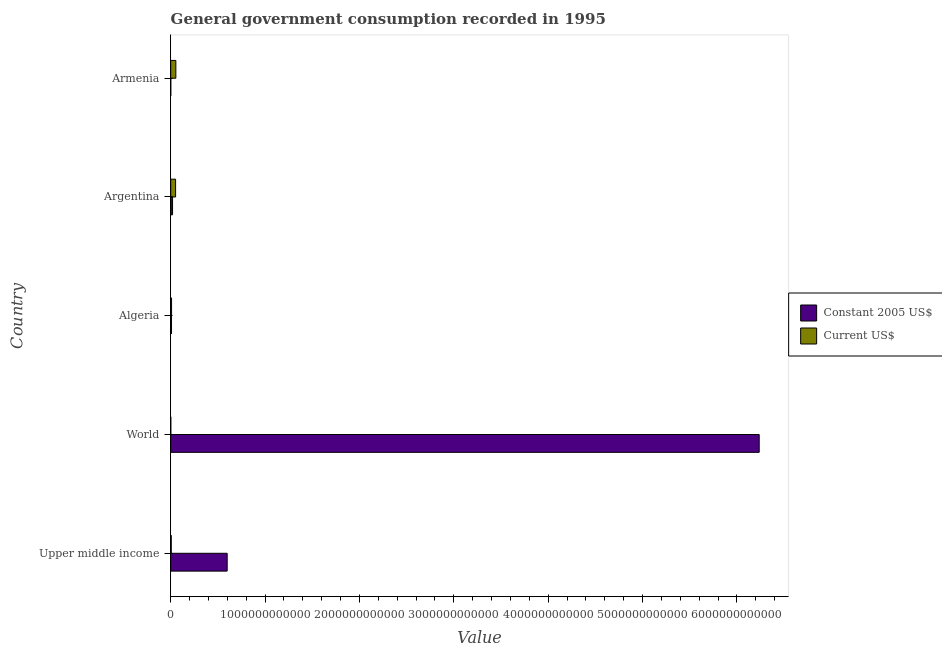How many different coloured bars are there?
Your answer should be very brief. 2. Are the number of bars per tick equal to the number of legend labels?
Your answer should be very brief. Yes. How many bars are there on the 1st tick from the top?
Offer a very short reply. 2. What is the label of the 4th group of bars from the top?
Provide a short and direct response. World. What is the value consumed in current us$ in Upper middle income?
Give a very brief answer. 5.51e+09. Across all countries, what is the maximum value consumed in current us$?
Offer a terse response. 5.43e+1. Across all countries, what is the minimum value consumed in current us$?
Provide a short and direct response. 7.15e+08. In which country was the value consumed in current us$ maximum?
Keep it short and to the point. Armenia. In which country was the value consumed in constant 2005 us$ minimum?
Your response must be concise. Armenia. What is the total value consumed in current us$ in the graph?
Give a very brief answer. 1.21e+11. What is the difference between the value consumed in constant 2005 us$ in Algeria and that in World?
Keep it short and to the point. -6.23e+12. What is the difference between the value consumed in constant 2005 us$ in Argentina and the value consumed in current us$ in Algeria?
Make the answer very short. 1.04e+1. What is the average value consumed in current us$ per country?
Your answer should be very brief. 2.42e+1. What is the difference between the value consumed in constant 2005 us$ and value consumed in current us$ in Argentina?
Provide a succinct answer. -3.24e+1. In how many countries, is the value consumed in current us$ greater than 5600000000000 ?
Provide a short and direct response. 0. What is the ratio of the value consumed in constant 2005 us$ in Argentina to that in Armenia?
Your answer should be very brief. 58.47. Is the value consumed in current us$ in Armenia less than that in World?
Make the answer very short. No. What is the difference between the highest and the second highest value consumed in constant 2005 us$?
Offer a very short reply. 5.64e+12. What is the difference between the highest and the lowest value consumed in current us$?
Ensure brevity in your answer.  5.36e+1. Is the sum of the value consumed in current us$ in Algeria and Upper middle income greater than the maximum value consumed in constant 2005 us$ across all countries?
Keep it short and to the point. No. What does the 2nd bar from the top in Upper middle income represents?
Provide a short and direct response. Constant 2005 US$. What does the 2nd bar from the bottom in Algeria represents?
Give a very brief answer. Current US$. How many bars are there?
Provide a short and direct response. 10. How many countries are there in the graph?
Make the answer very short. 5. What is the difference between two consecutive major ticks on the X-axis?
Ensure brevity in your answer.  1.00e+12. Are the values on the major ticks of X-axis written in scientific E-notation?
Offer a very short reply. No. Does the graph contain any zero values?
Ensure brevity in your answer.  No. Where does the legend appear in the graph?
Ensure brevity in your answer.  Center right. How many legend labels are there?
Your answer should be compact. 2. How are the legend labels stacked?
Ensure brevity in your answer.  Vertical. What is the title of the graph?
Give a very brief answer. General government consumption recorded in 1995. Does "Investment in Telecom" appear as one of the legend labels in the graph?
Offer a terse response. No. What is the label or title of the X-axis?
Provide a short and direct response. Value. What is the Value of Constant 2005 US$ in Upper middle income?
Offer a terse response. 5.98e+11. What is the Value in Current US$ in Upper middle income?
Your answer should be very brief. 5.51e+09. What is the Value of Constant 2005 US$ in World?
Provide a short and direct response. 6.24e+12. What is the Value of Current US$ in World?
Your answer should be compact. 7.15e+08. What is the Value in Constant 2005 US$ in Algeria?
Make the answer very short. 8.51e+09. What is the Value in Current US$ in Algeria?
Offer a terse response. 9.02e+09. What is the Value of Constant 2005 US$ in Argentina?
Your answer should be very brief. 1.94e+1. What is the Value of Current US$ in Argentina?
Give a very brief answer. 5.17e+1. What is the Value in Constant 2005 US$ in Armenia?
Your answer should be very brief. 3.31e+08. What is the Value in Current US$ in Armenia?
Provide a short and direct response. 5.43e+1. Across all countries, what is the maximum Value of Constant 2005 US$?
Your answer should be compact. 6.24e+12. Across all countries, what is the maximum Value in Current US$?
Keep it short and to the point. 5.43e+1. Across all countries, what is the minimum Value in Constant 2005 US$?
Provide a succinct answer. 3.31e+08. Across all countries, what is the minimum Value of Current US$?
Offer a very short reply. 7.15e+08. What is the total Value in Constant 2005 US$ in the graph?
Offer a very short reply. 6.86e+12. What is the total Value in Current US$ in the graph?
Provide a short and direct response. 1.21e+11. What is the difference between the Value in Constant 2005 US$ in Upper middle income and that in World?
Your answer should be very brief. -5.64e+12. What is the difference between the Value in Current US$ in Upper middle income and that in World?
Offer a terse response. 4.80e+09. What is the difference between the Value of Constant 2005 US$ in Upper middle income and that in Algeria?
Ensure brevity in your answer.  5.90e+11. What is the difference between the Value in Current US$ in Upper middle income and that in Algeria?
Ensure brevity in your answer.  -3.51e+09. What is the difference between the Value of Constant 2005 US$ in Upper middle income and that in Argentina?
Keep it short and to the point. 5.79e+11. What is the difference between the Value in Current US$ in Upper middle income and that in Argentina?
Give a very brief answer. -4.62e+1. What is the difference between the Value of Constant 2005 US$ in Upper middle income and that in Armenia?
Keep it short and to the point. 5.98e+11. What is the difference between the Value of Current US$ in Upper middle income and that in Armenia?
Make the answer very short. -4.88e+1. What is the difference between the Value of Constant 2005 US$ in World and that in Algeria?
Provide a short and direct response. 6.23e+12. What is the difference between the Value in Current US$ in World and that in Algeria?
Keep it short and to the point. -8.31e+09. What is the difference between the Value of Constant 2005 US$ in World and that in Argentina?
Provide a succinct answer. 6.22e+12. What is the difference between the Value in Current US$ in World and that in Argentina?
Your answer should be very brief. -5.10e+1. What is the difference between the Value in Constant 2005 US$ in World and that in Armenia?
Make the answer very short. 6.24e+12. What is the difference between the Value in Current US$ in World and that in Armenia?
Ensure brevity in your answer.  -5.36e+1. What is the difference between the Value of Constant 2005 US$ in Algeria and that in Argentina?
Provide a succinct answer. -1.09e+1. What is the difference between the Value of Current US$ in Algeria and that in Argentina?
Provide a short and direct response. -4.27e+1. What is the difference between the Value of Constant 2005 US$ in Algeria and that in Armenia?
Provide a succinct answer. 8.18e+09. What is the difference between the Value in Current US$ in Algeria and that in Armenia?
Offer a terse response. -4.52e+1. What is the difference between the Value in Constant 2005 US$ in Argentina and that in Armenia?
Make the answer very short. 1.90e+1. What is the difference between the Value in Current US$ in Argentina and that in Armenia?
Your answer should be compact. -2.54e+09. What is the difference between the Value of Constant 2005 US$ in Upper middle income and the Value of Current US$ in World?
Your response must be concise. 5.98e+11. What is the difference between the Value in Constant 2005 US$ in Upper middle income and the Value in Current US$ in Algeria?
Make the answer very short. 5.89e+11. What is the difference between the Value in Constant 2005 US$ in Upper middle income and the Value in Current US$ in Argentina?
Keep it short and to the point. 5.47e+11. What is the difference between the Value of Constant 2005 US$ in Upper middle income and the Value of Current US$ in Armenia?
Provide a short and direct response. 5.44e+11. What is the difference between the Value in Constant 2005 US$ in World and the Value in Current US$ in Algeria?
Provide a short and direct response. 6.23e+12. What is the difference between the Value of Constant 2005 US$ in World and the Value of Current US$ in Argentina?
Ensure brevity in your answer.  6.18e+12. What is the difference between the Value in Constant 2005 US$ in World and the Value in Current US$ in Armenia?
Keep it short and to the point. 6.18e+12. What is the difference between the Value of Constant 2005 US$ in Algeria and the Value of Current US$ in Argentina?
Your response must be concise. -4.32e+1. What is the difference between the Value in Constant 2005 US$ in Algeria and the Value in Current US$ in Armenia?
Make the answer very short. -4.58e+1. What is the difference between the Value of Constant 2005 US$ in Argentina and the Value of Current US$ in Armenia?
Offer a terse response. -3.49e+1. What is the average Value in Constant 2005 US$ per country?
Your answer should be compact. 1.37e+12. What is the average Value in Current US$ per country?
Offer a terse response. 2.42e+1. What is the difference between the Value of Constant 2005 US$ and Value of Current US$ in Upper middle income?
Provide a short and direct response. 5.93e+11. What is the difference between the Value in Constant 2005 US$ and Value in Current US$ in World?
Provide a short and direct response. 6.24e+12. What is the difference between the Value of Constant 2005 US$ and Value of Current US$ in Algeria?
Provide a succinct answer. -5.08e+08. What is the difference between the Value in Constant 2005 US$ and Value in Current US$ in Argentina?
Your answer should be compact. -3.24e+1. What is the difference between the Value of Constant 2005 US$ and Value of Current US$ in Armenia?
Offer a very short reply. -5.39e+1. What is the ratio of the Value of Constant 2005 US$ in Upper middle income to that in World?
Offer a terse response. 0.1. What is the ratio of the Value in Current US$ in Upper middle income to that in World?
Offer a very short reply. 7.71. What is the ratio of the Value of Constant 2005 US$ in Upper middle income to that in Algeria?
Your answer should be compact. 70.28. What is the ratio of the Value of Current US$ in Upper middle income to that in Algeria?
Provide a succinct answer. 0.61. What is the ratio of the Value of Constant 2005 US$ in Upper middle income to that in Argentina?
Keep it short and to the point. 30.88. What is the ratio of the Value of Current US$ in Upper middle income to that in Argentina?
Offer a terse response. 0.11. What is the ratio of the Value of Constant 2005 US$ in Upper middle income to that in Armenia?
Provide a short and direct response. 1805.53. What is the ratio of the Value of Current US$ in Upper middle income to that in Armenia?
Make the answer very short. 0.1. What is the ratio of the Value of Constant 2005 US$ in World to that in Algeria?
Provide a succinct answer. 732.53. What is the ratio of the Value of Current US$ in World to that in Algeria?
Provide a succinct answer. 0.08. What is the ratio of the Value in Constant 2005 US$ in World to that in Argentina?
Your response must be concise. 321.86. What is the ratio of the Value of Current US$ in World to that in Argentina?
Keep it short and to the point. 0.01. What is the ratio of the Value of Constant 2005 US$ in World to that in Armenia?
Give a very brief answer. 1.88e+04. What is the ratio of the Value of Current US$ in World to that in Armenia?
Offer a terse response. 0.01. What is the ratio of the Value in Constant 2005 US$ in Algeria to that in Argentina?
Offer a terse response. 0.44. What is the ratio of the Value of Current US$ in Algeria to that in Argentina?
Make the answer very short. 0.17. What is the ratio of the Value of Constant 2005 US$ in Algeria to that in Armenia?
Provide a short and direct response. 25.69. What is the ratio of the Value in Current US$ in Algeria to that in Armenia?
Give a very brief answer. 0.17. What is the ratio of the Value in Constant 2005 US$ in Argentina to that in Armenia?
Give a very brief answer. 58.47. What is the ratio of the Value of Current US$ in Argentina to that in Armenia?
Ensure brevity in your answer.  0.95. What is the difference between the highest and the second highest Value of Constant 2005 US$?
Ensure brevity in your answer.  5.64e+12. What is the difference between the highest and the second highest Value in Current US$?
Provide a succinct answer. 2.54e+09. What is the difference between the highest and the lowest Value in Constant 2005 US$?
Offer a very short reply. 6.24e+12. What is the difference between the highest and the lowest Value of Current US$?
Provide a succinct answer. 5.36e+1. 